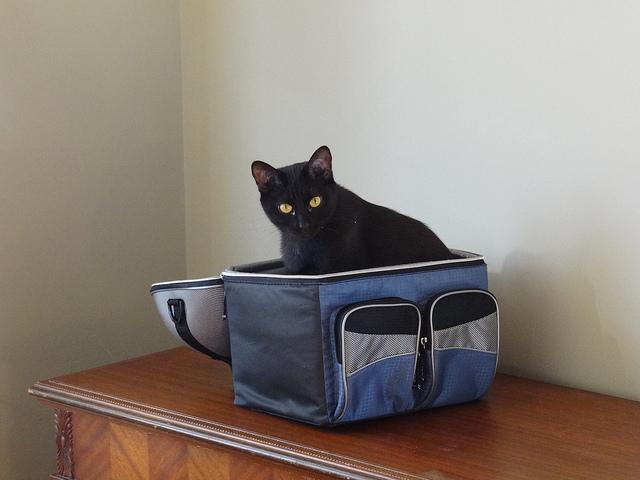What colors are the bins?
Answer briefly. Blue. Can you see the cats tail?
Write a very short answer. No. Is the cat sitting in a pet carrier?
Concise answer only. No. Is this the cat's bed?
Write a very short answer. No. Is the cat playing?
Quick response, please. No. Is this a calico cat?
Concise answer only. No. 